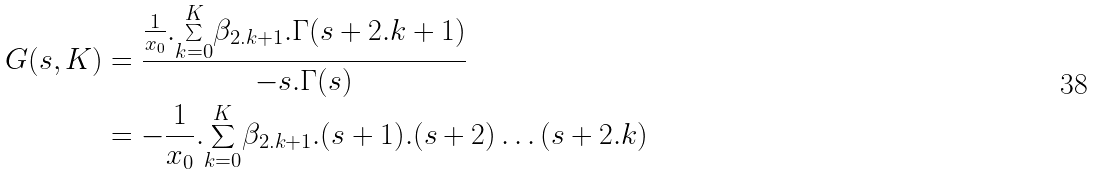<formula> <loc_0><loc_0><loc_500><loc_500>G ( s , K ) & = \frac { \frac { 1 } { x _ { 0 } } . \underset { k = 0 } { \overset { K } { \sum } } \beta _ { 2 . k + 1 } . \Gamma ( s + 2 . k + 1 ) } { - s . \Gamma ( s ) } \\ & = - \frac { 1 } { x _ { 0 } } . \underset { k = 0 } { \overset { K } { \sum } } \beta _ { 2 . k + 1 } . ( s + 1 ) . ( s + 2 ) \dots ( s + 2 . k )</formula> 